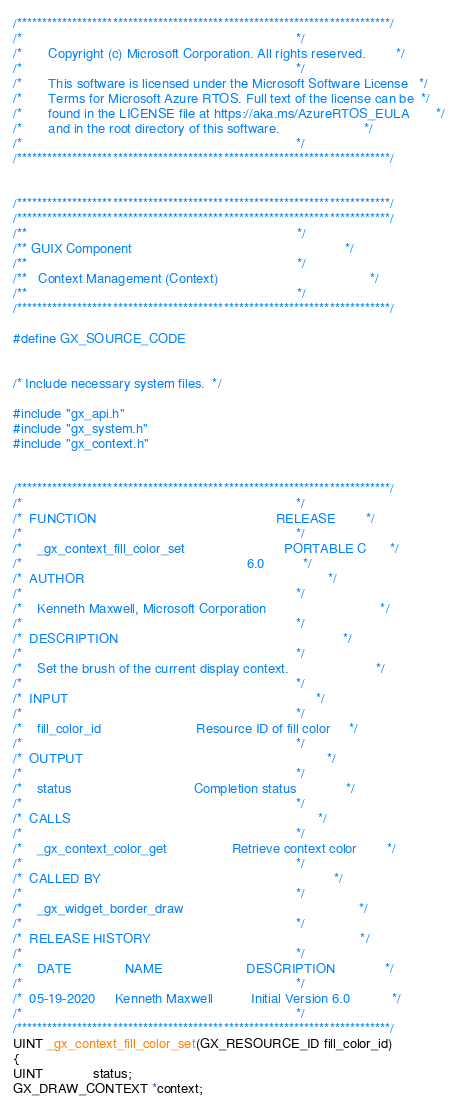<code> <loc_0><loc_0><loc_500><loc_500><_C_>/**************************************************************************/
/*                                                                        */
/*       Copyright (c) Microsoft Corporation. All rights reserved.        */
/*                                                                        */
/*       This software is licensed under the Microsoft Software License   */
/*       Terms for Microsoft Azure RTOS. Full text of the license can be  */
/*       found in the LICENSE file at https://aka.ms/AzureRTOS_EULA       */
/*       and in the root directory of this software.                      */
/*                                                                        */
/**************************************************************************/


/**************************************************************************/
/**************************************************************************/
/**                                                                       */
/** GUIX Component                                                        */
/**                                                                       */
/**   Context Management (Context)                                        */
/**                                                                       */
/**************************************************************************/

#define GX_SOURCE_CODE


/* Include necessary system files.  */

#include "gx_api.h"
#include "gx_system.h"
#include "gx_context.h"


/**************************************************************************/
/*                                                                        */
/*  FUNCTION                                               RELEASE        */
/*                                                                        */
/*    _gx_context_fill_color_set                          PORTABLE C      */
/*                                                           6.0          */
/*  AUTHOR                                                                */
/*                                                                        */
/*    Kenneth Maxwell, Microsoft Corporation                              */
/*                                                                        */
/*  DESCRIPTION                                                           */
/*                                                                        */
/*    Set the brush of the current display context.                       */
/*                                                                        */
/*  INPUT                                                                 */
/*                                                                        */
/*    fill_color_id                         Resource ID of fill color     */
/*                                                                        */
/*  OUTPUT                                                                */
/*                                                                        */
/*    status                                Completion status             */
/*                                                                        */
/*  CALLS                                                                 */
/*                                                                        */
/*    _gx_context_color_get                 Retrieve context color        */
/*                                                                        */
/*  CALLED BY                                                             */
/*                                                                        */
/*    _gx_widget_border_draw                                              */
/*                                                                        */
/*  RELEASE HISTORY                                                       */
/*                                                                        */
/*    DATE              NAME                      DESCRIPTION             */
/*                                                                        */
/*  05-19-2020     Kenneth Maxwell          Initial Version 6.0           */
/*                                                                        */
/**************************************************************************/
UINT _gx_context_fill_color_set(GX_RESOURCE_ID fill_color_id)
{
UINT             status;
GX_DRAW_CONTEXT *context;</code> 